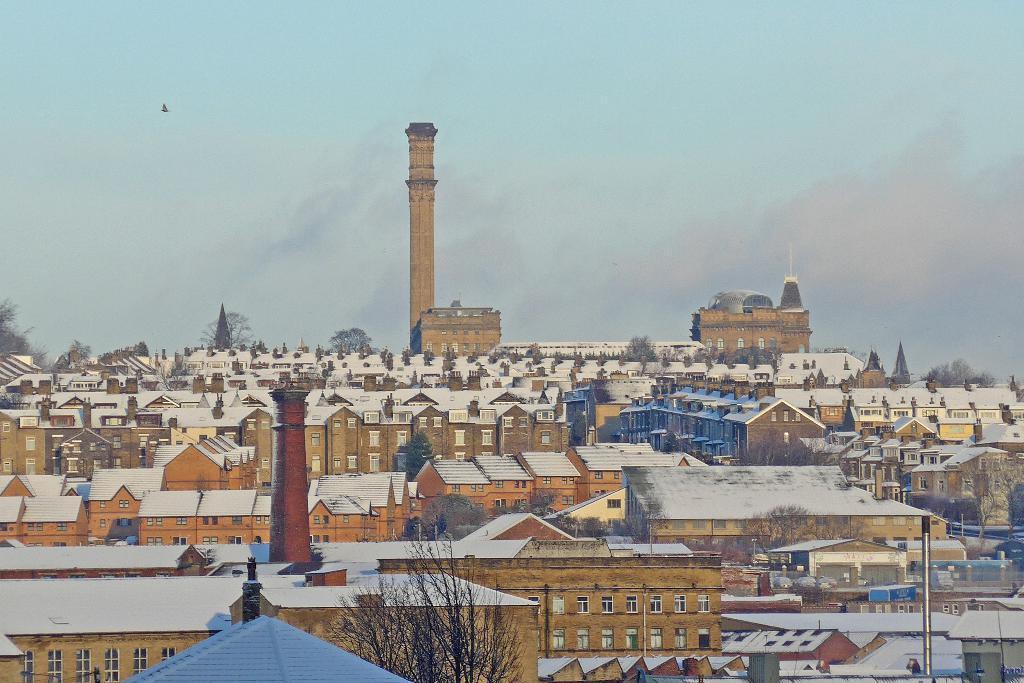In one or two sentences, can you explain what this image depicts? In this image I can see many buildings which are in white and brown color. I can see the trees and sky in the back. 